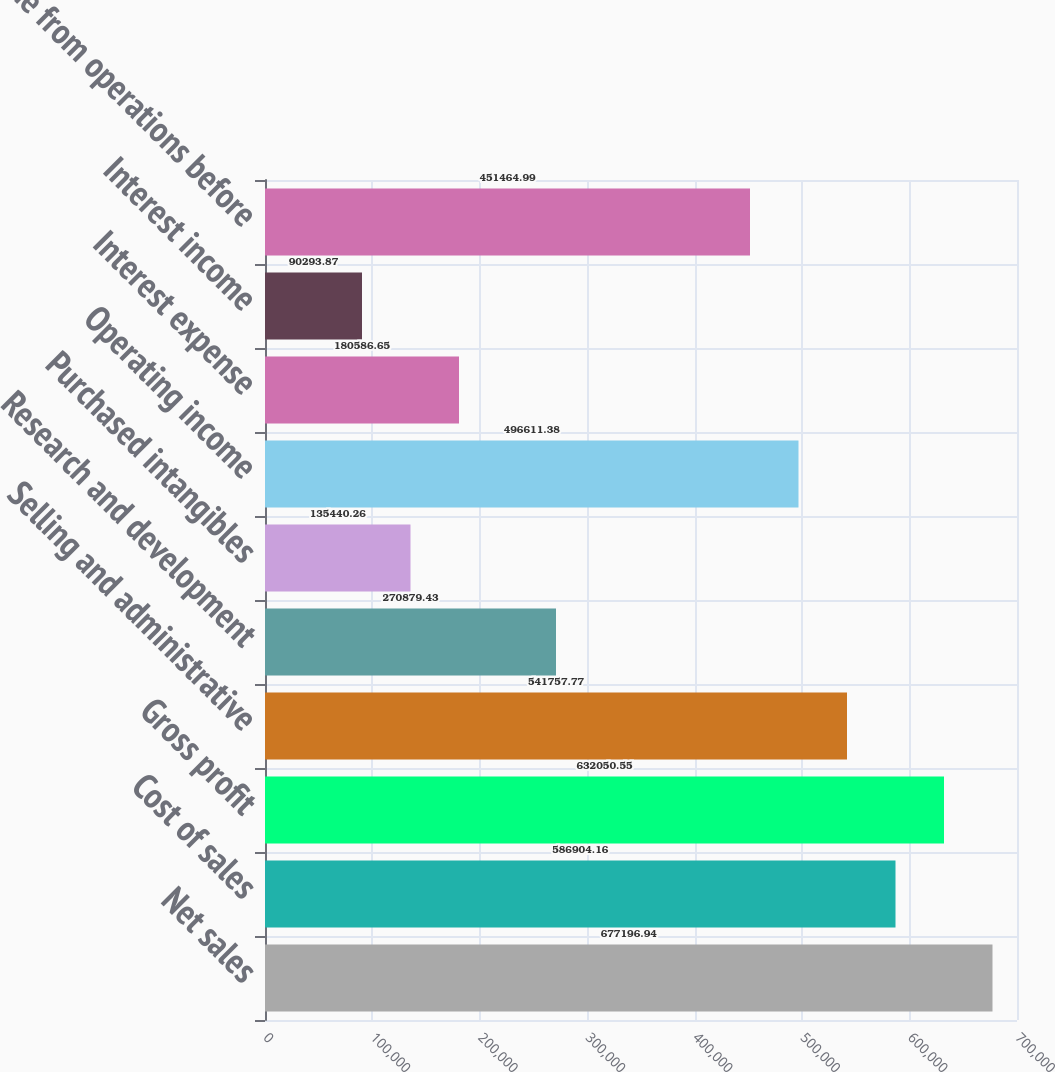<chart> <loc_0><loc_0><loc_500><loc_500><bar_chart><fcel>Net sales<fcel>Cost of sales<fcel>Gross profit<fcel>Selling and administrative<fcel>Research and development<fcel>Purchased intangibles<fcel>Operating income<fcel>Interest expense<fcel>Interest income<fcel>Income from operations before<nl><fcel>677197<fcel>586904<fcel>632051<fcel>541758<fcel>270879<fcel>135440<fcel>496611<fcel>180587<fcel>90293.9<fcel>451465<nl></chart> 